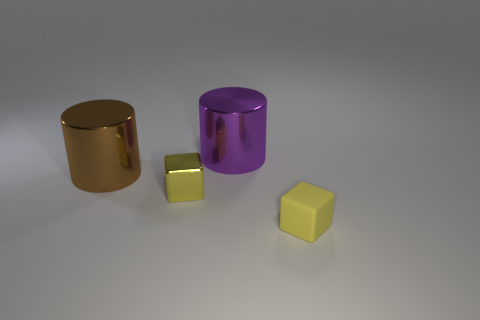What could the relative sizes of these objects tell us about their possible uses? The relative sizes suggest a variety of potential uses. The larger cylinder and cube could serve as decorative items or paperweights, while the smaller cube might be a die or a calibration cube for 3D rendering tests. 